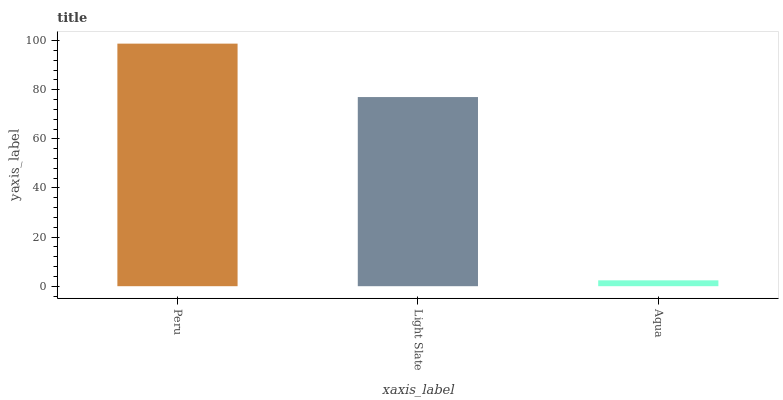Is Light Slate the minimum?
Answer yes or no. No. Is Light Slate the maximum?
Answer yes or no. No. Is Peru greater than Light Slate?
Answer yes or no. Yes. Is Light Slate less than Peru?
Answer yes or no. Yes. Is Light Slate greater than Peru?
Answer yes or no. No. Is Peru less than Light Slate?
Answer yes or no. No. Is Light Slate the high median?
Answer yes or no. Yes. Is Light Slate the low median?
Answer yes or no. Yes. Is Peru the high median?
Answer yes or no. No. Is Aqua the low median?
Answer yes or no. No. 